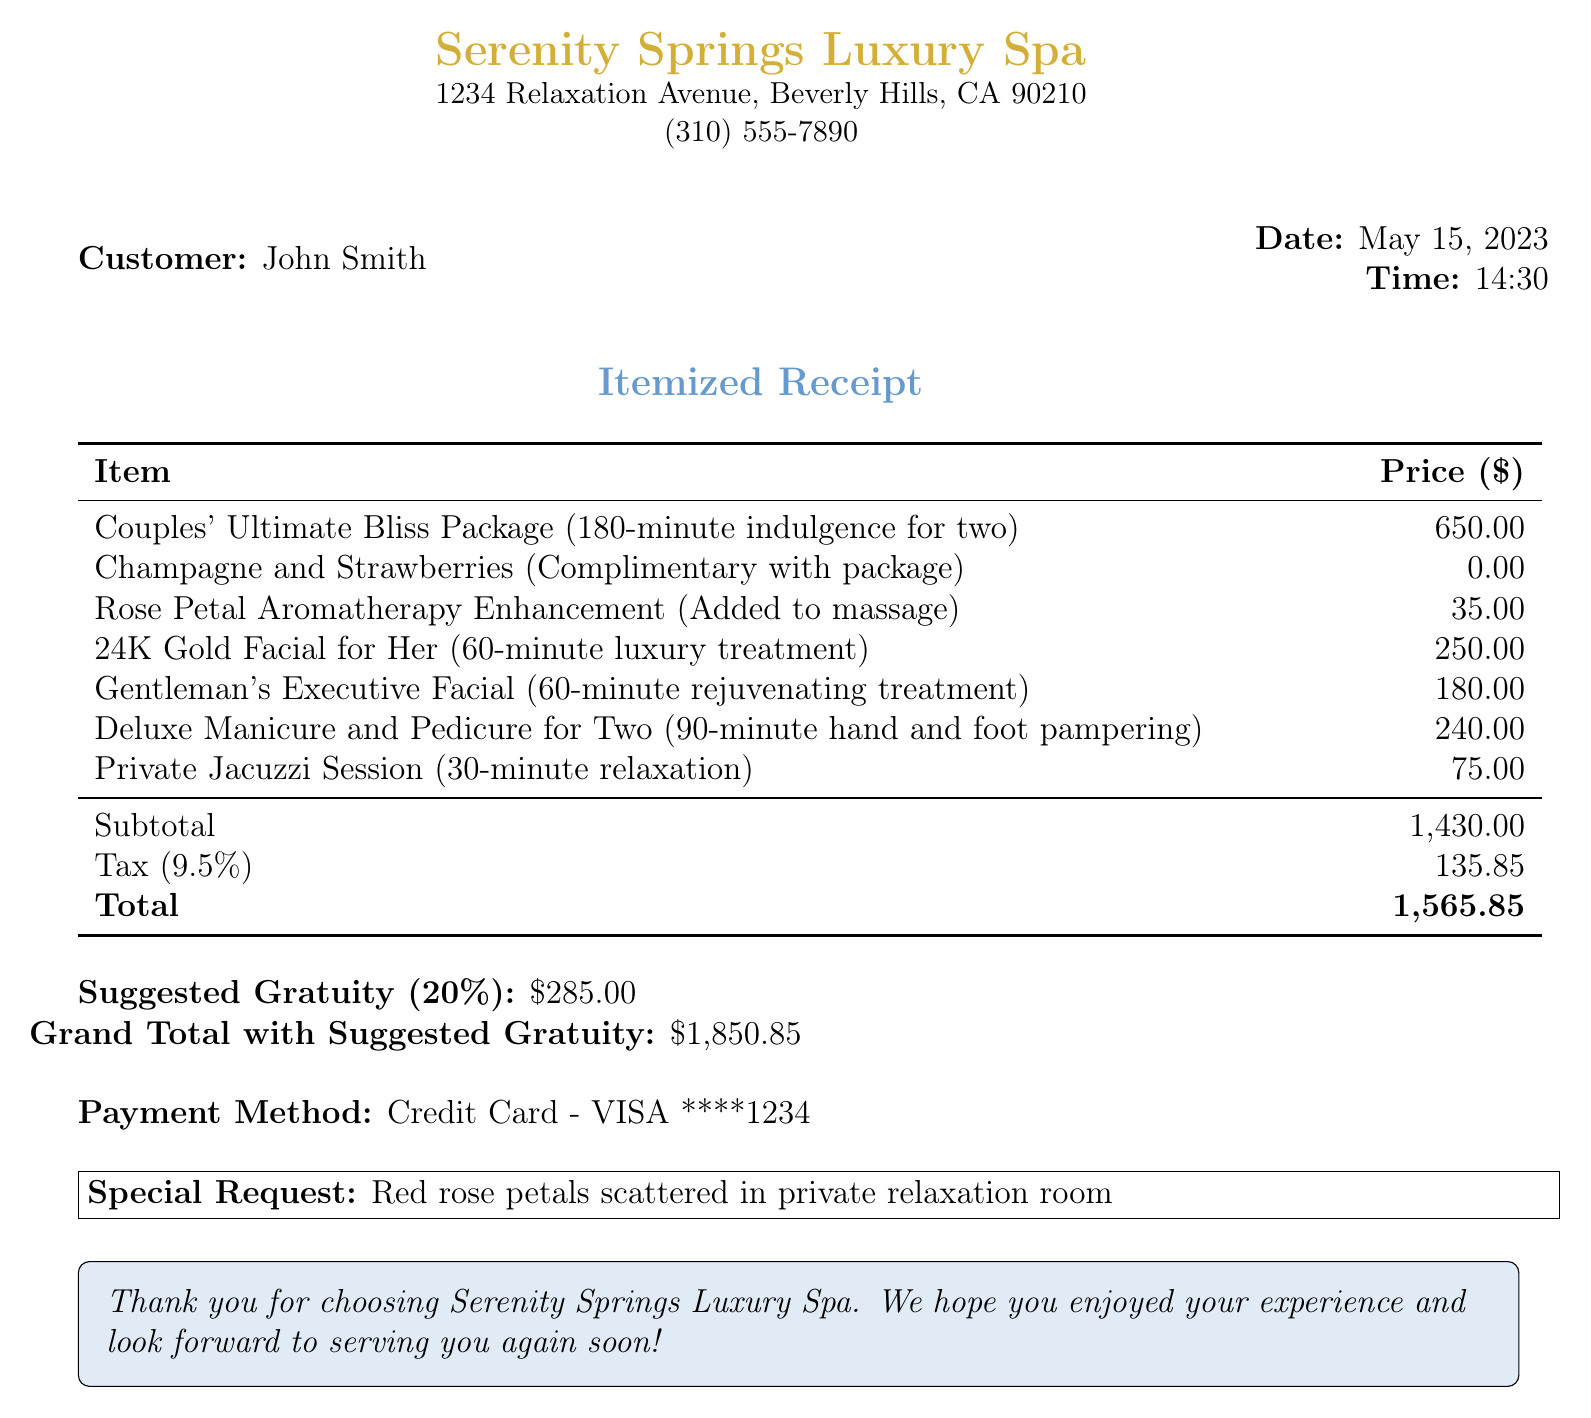What is the name of the spa? The name of the spa is listed at the top of the receipt.
Answer: Serenity Springs Luxury Spa What is the date of the visit? The receipt includes the date of service provided.
Answer: May 15, 2023 How much did the "Couples' Ultimate Bliss Package" cost? The price for the package is clearly shown in the itemized list.
Answer: 650.00 What is the subtotal amount? The total before tax and gratuity is detailed near the bottom of the receipt.
Answer: 1430.00 What is the total amount after gratuity? The document specifies the grand total that includes the suggested gratuity.
Answer: 1850.85 What special request was made? The receipt notes any special requests made by the customer.
Answer: Red rose petals scattered in private relaxation room What was the payment method used? The payment method can be found towards the end of the receipt.
Answer: Credit Card - VISA ****1234 What is the tax rate applied? The tax rate is mentioned alongside the tax amount in the receipt.
Answer: 9.5% How much was the suggested gratuity? The suggested gratuity amount is explicitly stated on the receipt.
Answer: 285.00 What kind of enhancement was added to the massage? The enhancement added to the massage is listed among the items on the receipt.
Answer: Rose Petal Aromatherapy Enhancement 